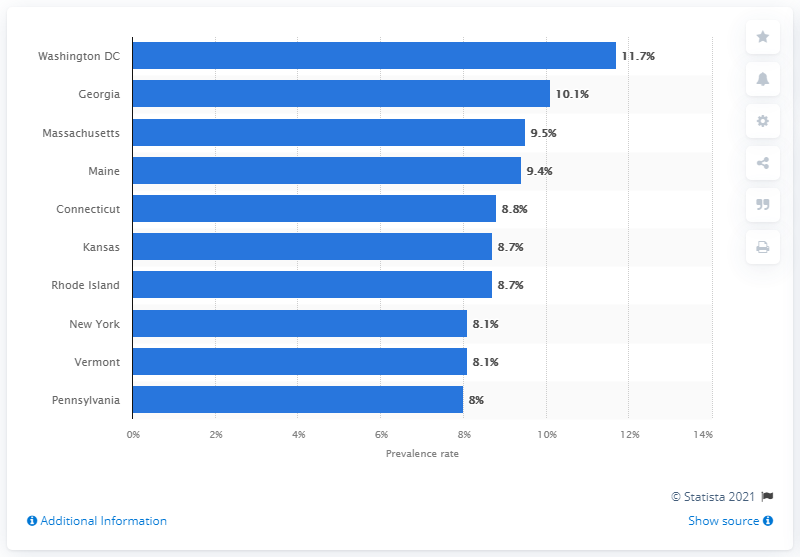Outline some significant characteristics in this image. The highest current prevalence of asthma among children was reported to be in Washington, D.C. 